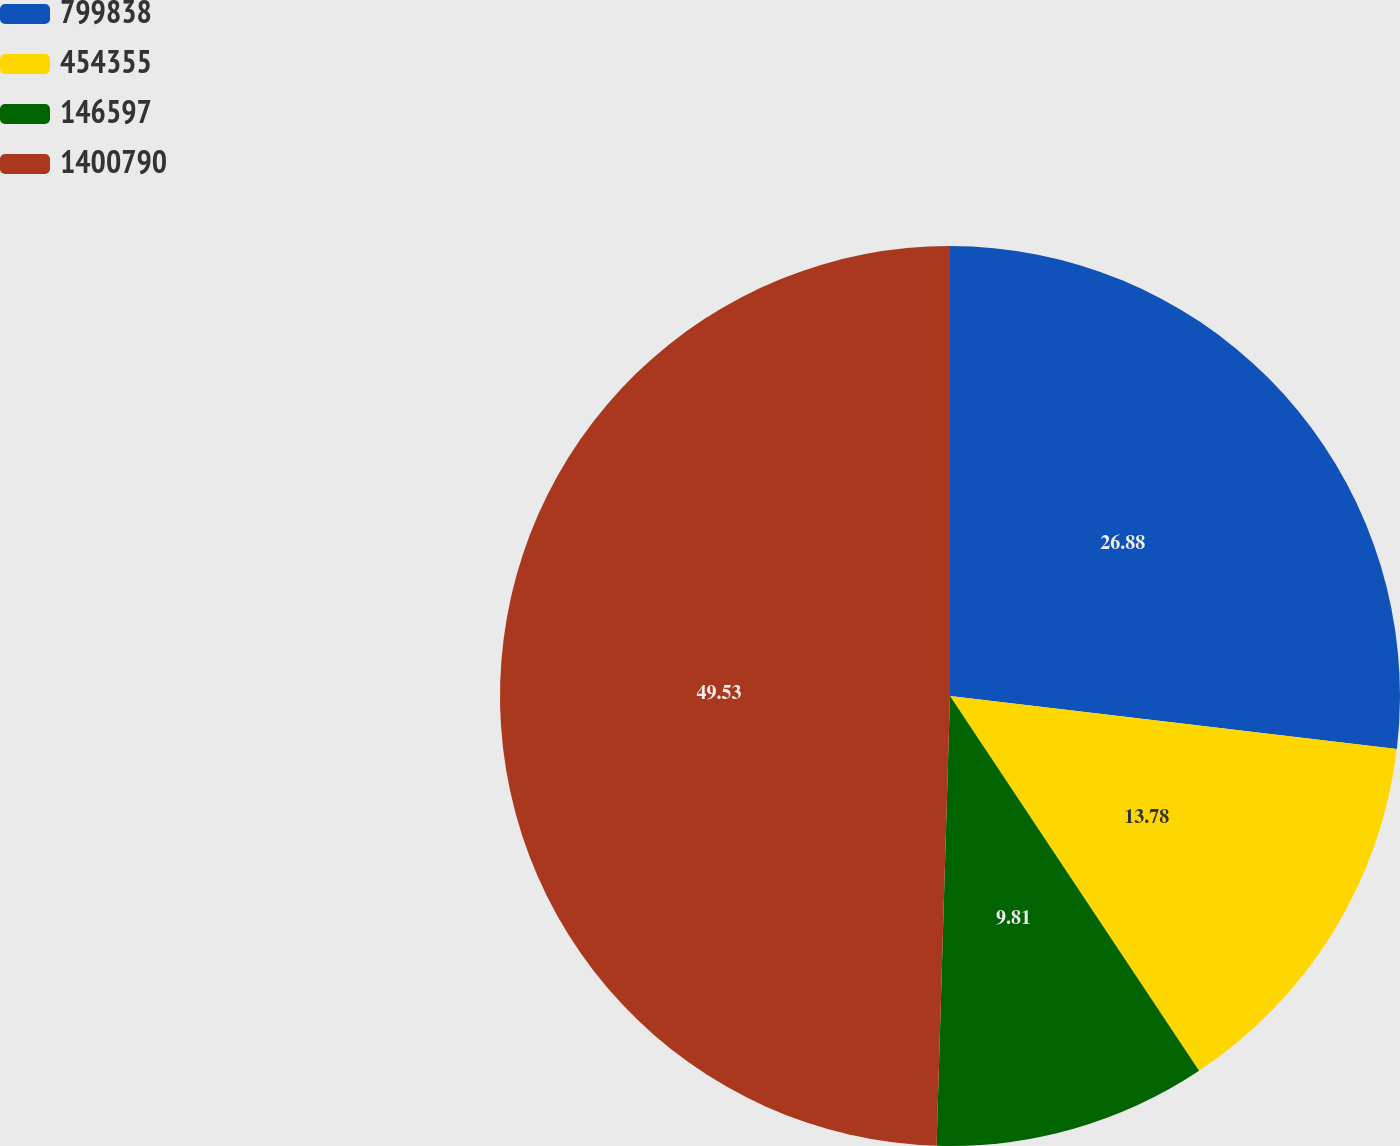Convert chart. <chart><loc_0><loc_0><loc_500><loc_500><pie_chart><fcel>799838<fcel>454355<fcel>146597<fcel>1400790<nl><fcel>26.88%<fcel>13.78%<fcel>9.81%<fcel>49.52%<nl></chart> 